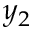Convert formula to latex. <formula><loc_0><loc_0><loc_500><loc_500>y _ { 2 }</formula> 